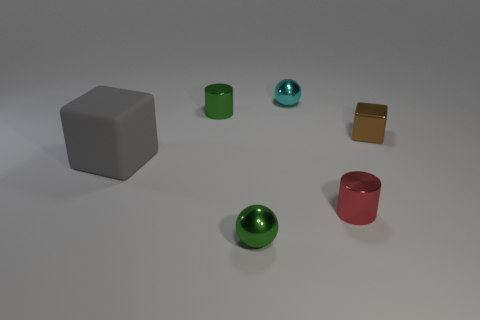What is the size of the sphere behind the large matte object?
Provide a succinct answer. Small. Is there another metal block that has the same color as the small metallic block?
Keep it short and to the point. No. Is the large block the same color as the small shiny block?
Your answer should be compact. No. How many tiny metallic cylinders are behind the small cylinder in front of the green cylinder?
Offer a very short reply. 1. What number of large gray blocks are the same material as the green ball?
Keep it short and to the point. 0. Are there any brown metal blocks on the left side of the tiny brown thing?
Provide a short and direct response. No. The other metallic ball that is the same size as the green shiny sphere is what color?
Keep it short and to the point. Cyan. How many things are either spheres that are in front of the red thing or gray rubber things?
Provide a succinct answer. 2. There is a thing that is on the left side of the tiny cyan metal ball and to the right of the tiny green metal cylinder; how big is it?
Give a very brief answer. Small. What number of other things are there of the same size as the red metal cylinder?
Your answer should be compact. 4. 